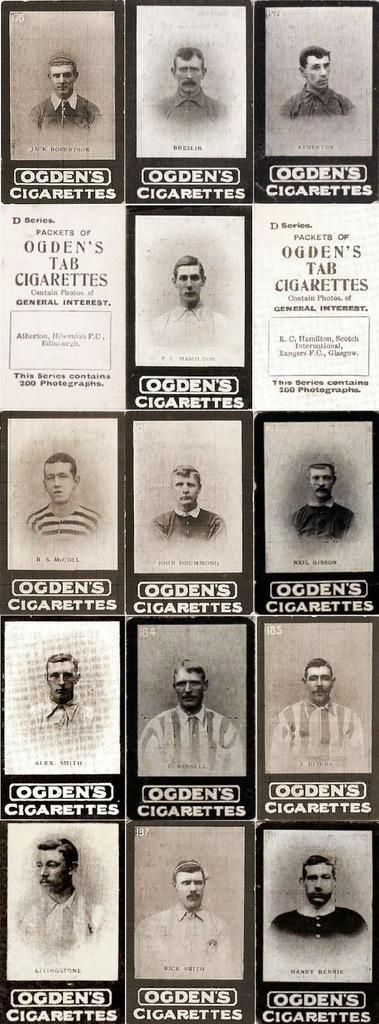In one or two sentences, can you explain what this image depicts? In the image we can see a poster. On the poster we can see the photographs of a few people. 